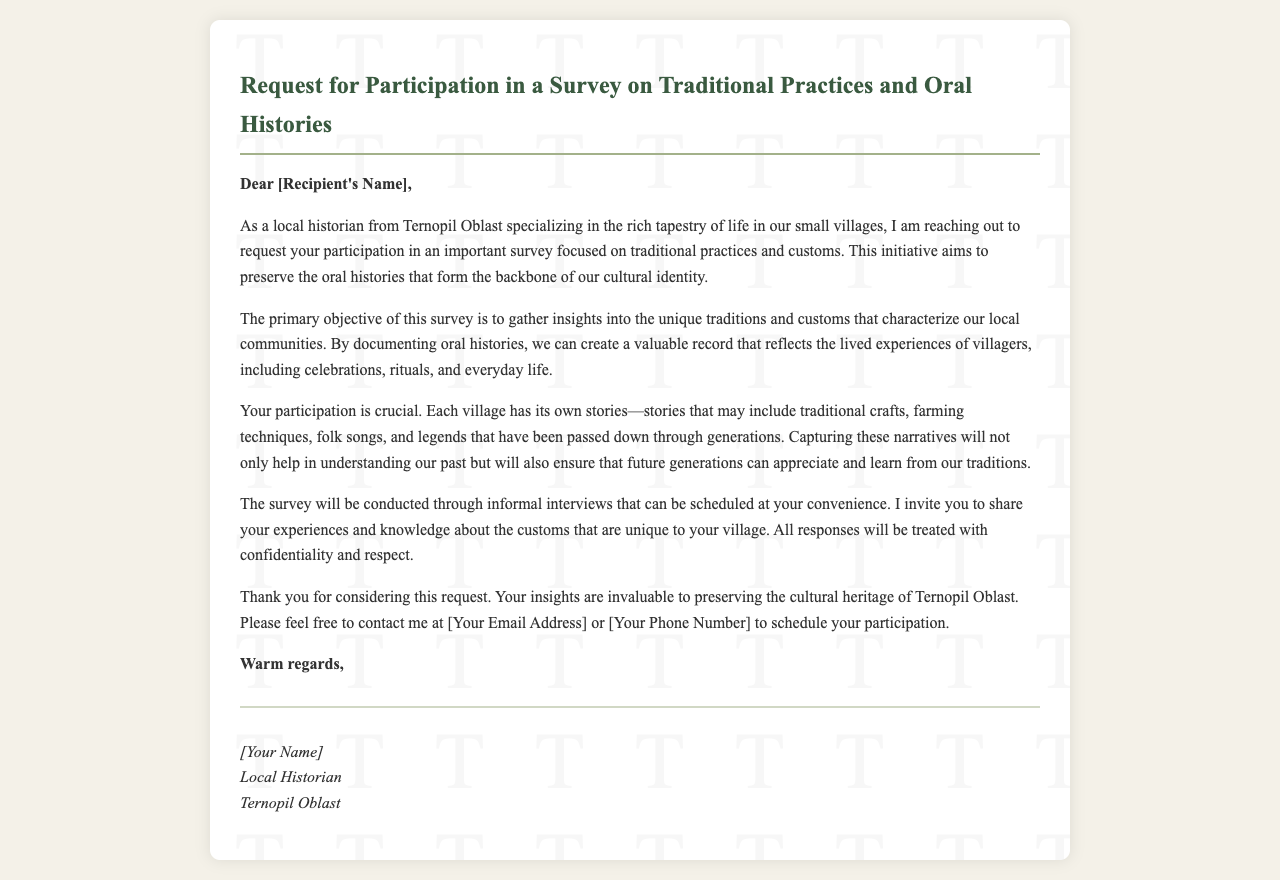What is the main focus of the survey? The main focus of the survey is on traditional practices and customs.
Answer: Traditional practices and customs Who is the sender of the mail? The sender is identified at the end of the document.
Answer: [Your Name] What is the purpose of documenting oral histories? The purpose is to preserve the cultural identity and record the lived experiences of villagers.
Answer: Preserve cultural identity What type of interviews will be conducted? The type of interviews mentioned in the document is informal interviews.
Answer: Informal interviews What will happen to the responses collected? The document states that all responses will be treated with confidentiality and respect.
Answer: Confidentiality and respect Why is participant involvement important according to the document? Participant involvement is important to capture unique village stories and traditions.
Answer: Unique village stories When can the interviews be scheduled? The interviews can be scheduled at the convenience of the participants.
Answer: At your convenience What title does the sender have? The title of the sender is mentioned in the footer of the document.
Answer: Local Historian In which geographical area is the survey focused? The survey is focused on Ternopil Oblast.
Answer: Ternopil Oblast What method is used to gather insights about the customs? The method used to gather insights is through interviews.
Answer: Interviews 